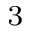<formula> <loc_0><loc_0><loc_500><loc_500>^ { 3 }</formula> 